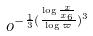Convert formula to latex. <formula><loc_0><loc_0><loc_500><loc_500>o ^ { - \frac { 1 } { 3 } ( \frac { \log \frac { x } { x _ { 6 } } } { \log \varpi } ) ^ { 3 } }</formula> 